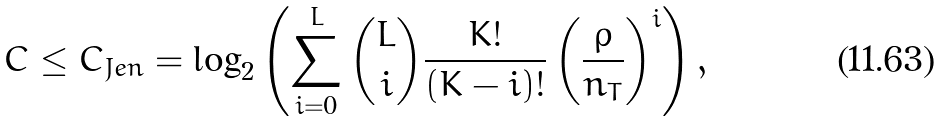Convert formula to latex. <formula><loc_0><loc_0><loc_500><loc_500>C \leq C _ { J e n } = \log _ { 2 } \left ( \sum _ { i = 0 } ^ { L } \binom { L } { i } \frac { K ! } { ( K - i ) ! } \left ( \frac { \rho } { n _ { T } } \right ) ^ { i } \right ) ,</formula> 